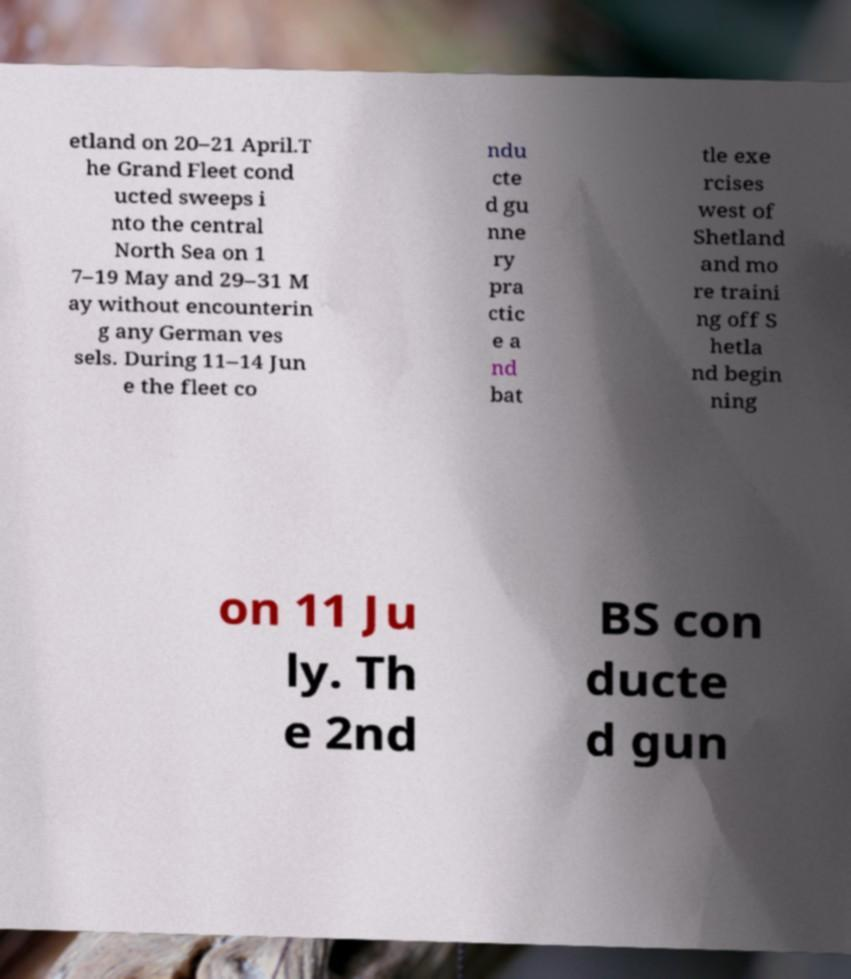I need the written content from this picture converted into text. Can you do that? etland on 20–21 April.T he Grand Fleet cond ucted sweeps i nto the central North Sea on 1 7–19 May and 29–31 M ay without encounterin g any German ves sels. During 11–14 Jun e the fleet co ndu cte d gu nne ry pra ctic e a nd bat tle exe rcises west of Shetland and mo re traini ng off S hetla nd begin ning on 11 Ju ly. Th e 2nd BS con ducte d gun 